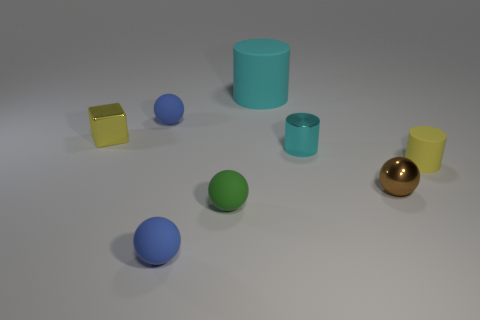Can you describe the lighting and mood conveyed by this scene? The lighting in the image is soft and diffused, casting gentle shadows and contributing to a calm, composed atmosphere. It seems to be a controlled, indoor environment, likely a rendered scene, where the primary focus is on the objects and their colors. 